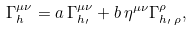<formula> <loc_0><loc_0><loc_500><loc_500>\Gamma _ { h } ^ { \mu \nu } = a \, \Gamma _ { h _ { \prime } } ^ { \mu \nu } + b \, \eta ^ { \mu \nu } \Gamma _ { h _ { \prime } \, \rho } ^ { \rho } ,</formula> 